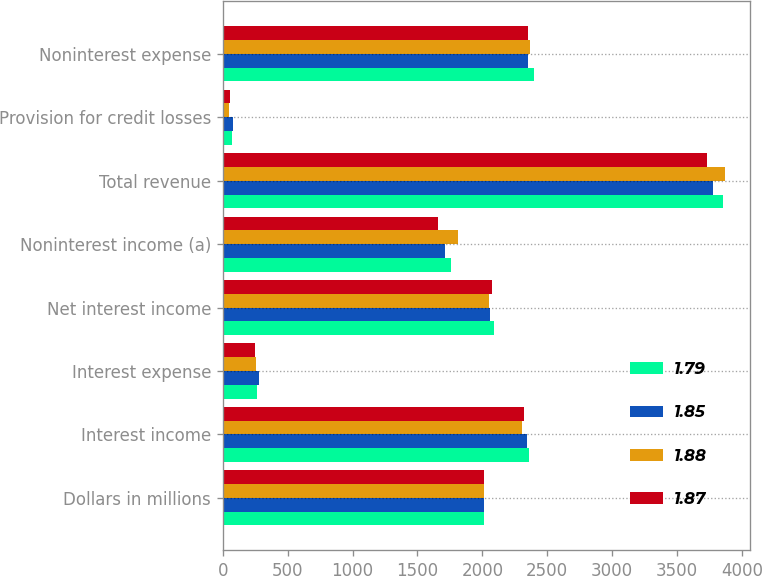Convert chart. <chart><loc_0><loc_0><loc_500><loc_500><stacked_bar_chart><ecel><fcel>Dollars in millions<fcel>Interest income<fcel>Interest expense<fcel>Net interest income<fcel>Noninterest income (a)<fcel>Total revenue<fcel>Provision for credit losses<fcel>Noninterest expense<nl><fcel>1.79<fcel>2015<fcel>2358<fcel>266<fcel>2092<fcel>1761<fcel>3853<fcel>74<fcel>2396<nl><fcel>1.85<fcel>2015<fcel>2341<fcel>279<fcel>2062<fcel>1713<fcel>3775<fcel>81<fcel>2352<nl><fcel>1.88<fcel>2015<fcel>2305<fcel>253<fcel>2052<fcel>1814<fcel>3866<fcel>46<fcel>2366<nl><fcel>1.87<fcel>2015<fcel>2319<fcel>247<fcel>2072<fcel>1659<fcel>3731<fcel>54<fcel>2349<nl></chart> 